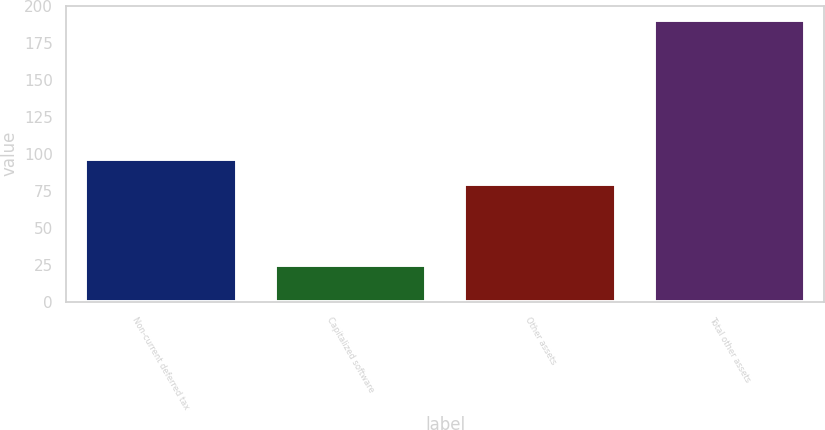<chart> <loc_0><loc_0><loc_500><loc_500><bar_chart><fcel>Non-current deferred tax<fcel>Capitalized software<fcel>Other assets<fcel>Total other assets<nl><fcel>96.6<fcel>25<fcel>80<fcel>191<nl></chart> 